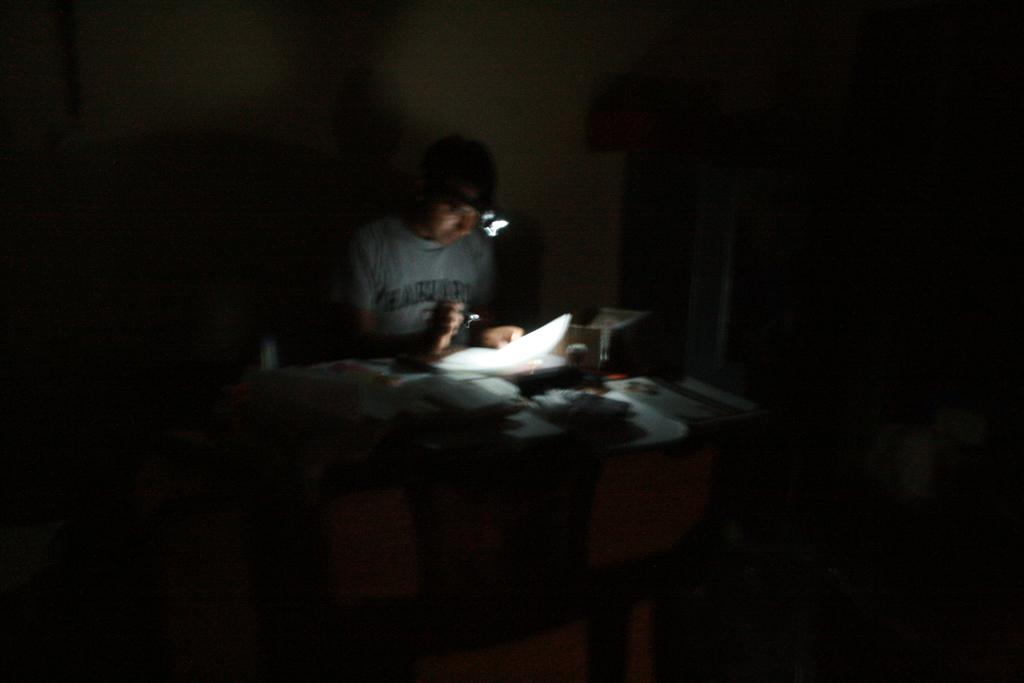What is the person in the image doing? The person is playing a piano. What object is the person using to create music? The person is using a piano. Can you describe the person's activity in more detail? The person is sitting at the piano and using their hands to press the keys. What type of cracker is the person eating while playing the piano? There is no cracker present in the image; the person is focused on playing the piano. What class is the person attending while playing the piano? The image does not show the person attending any class; they are solely focused on playing the piano. 